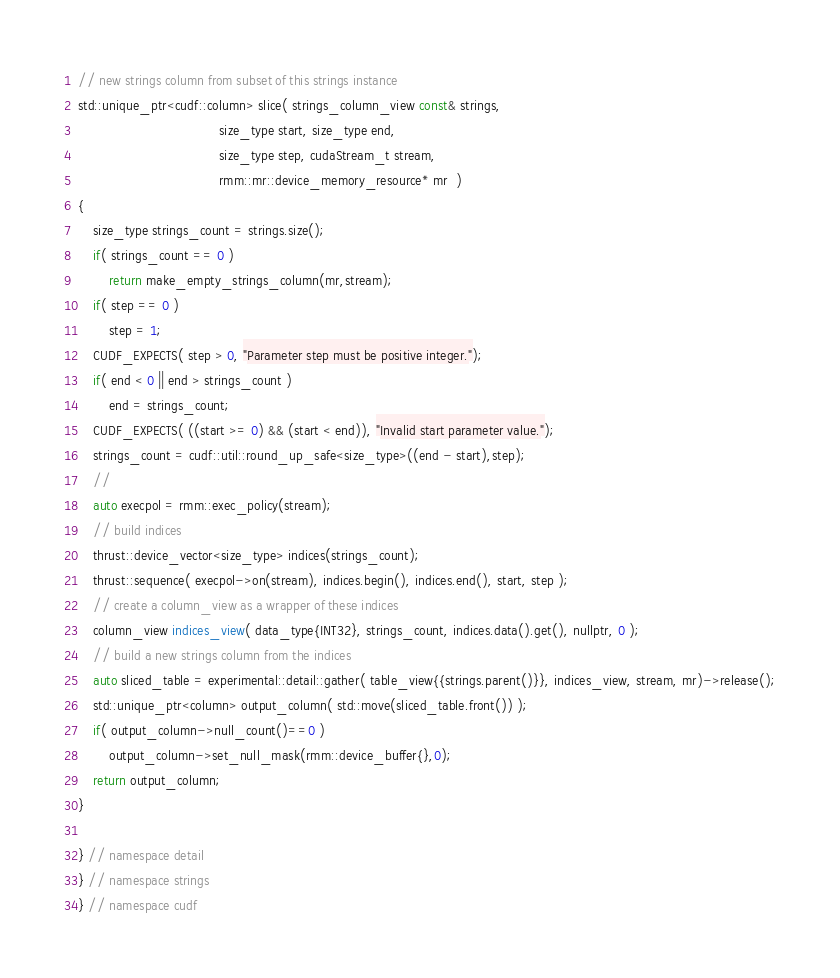Convert code to text. <code><loc_0><loc_0><loc_500><loc_500><_Cuda_>
// new strings column from subset of this strings instance
std::unique_ptr<cudf::column> slice( strings_column_view const& strings,
                                     size_type start, size_type end,
                                     size_type step, cudaStream_t stream,
                                     rmm::mr::device_memory_resource* mr  )
{
    size_type strings_count = strings.size();
    if( strings_count == 0 )
        return make_empty_strings_column(mr,stream);
    if( step == 0 )
        step = 1;
    CUDF_EXPECTS( step > 0, "Parameter step must be positive integer.");
    if( end < 0 || end > strings_count )
        end = strings_count;
    CUDF_EXPECTS( ((start >= 0) && (start < end)), "Invalid start parameter value.");
    strings_count = cudf::util::round_up_safe<size_type>((end - start),step);
    //
    auto execpol = rmm::exec_policy(stream);
    // build indices
    thrust::device_vector<size_type> indices(strings_count);
    thrust::sequence( execpol->on(stream), indices.begin(), indices.end(), start, step );
    // create a column_view as a wrapper of these indices
    column_view indices_view( data_type{INT32}, strings_count, indices.data().get(), nullptr, 0 );
    // build a new strings column from the indices
    auto sliced_table = experimental::detail::gather( table_view{{strings.parent()}}, indices_view, stream, mr)->release();
    std::unique_ptr<column> output_column( std::move(sliced_table.front()) );
    if( output_column->null_count()==0 )
        output_column->set_null_mask(rmm::device_buffer{},0);
    return output_column;
}

} // namespace detail
} // namespace strings
} // namespace cudf
</code> 